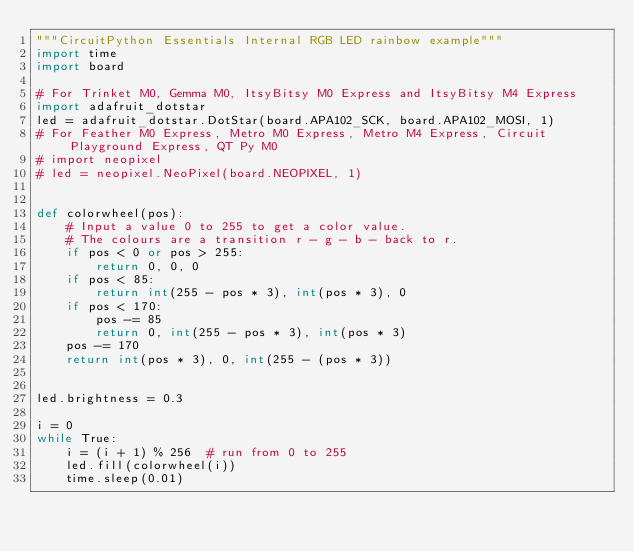<code> <loc_0><loc_0><loc_500><loc_500><_Python_>"""CircuitPython Essentials Internal RGB LED rainbow example"""
import time
import board

# For Trinket M0, Gemma M0, ItsyBitsy M0 Express and ItsyBitsy M4 Express
import adafruit_dotstar
led = adafruit_dotstar.DotStar(board.APA102_SCK, board.APA102_MOSI, 1)
# For Feather M0 Express, Metro M0 Express, Metro M4 Express, Circuit Playground Express, QT Py M0
# import neopixel
# led = neopixel.NeoPixel(board.NEOPIXEL, 1)


def colorwheel(pos):
    # Input a value 0 to 255 to get a color value.
    # The colours are a transition r - g - b - back to r.
    if pos < 0 or pos > 255:
        return 0, 0, 0
    if pos < 85:
        return int(255 - pos * 3), int(pos * 3), 0
    if pos < 170:
        pos -= 85
        return 0, int(255 - pos * 3), int(pos * 3)
    pos -= 170
    return int(pos * 3), 0, int(255 - (pos * 3))


led.brightness = 0.3

i = 0
while True:
    i = (i + 1) % 256  # run from 0 to 255
    led.fill(colorwheel(i))
    time.sleep(0.01)
</code> 